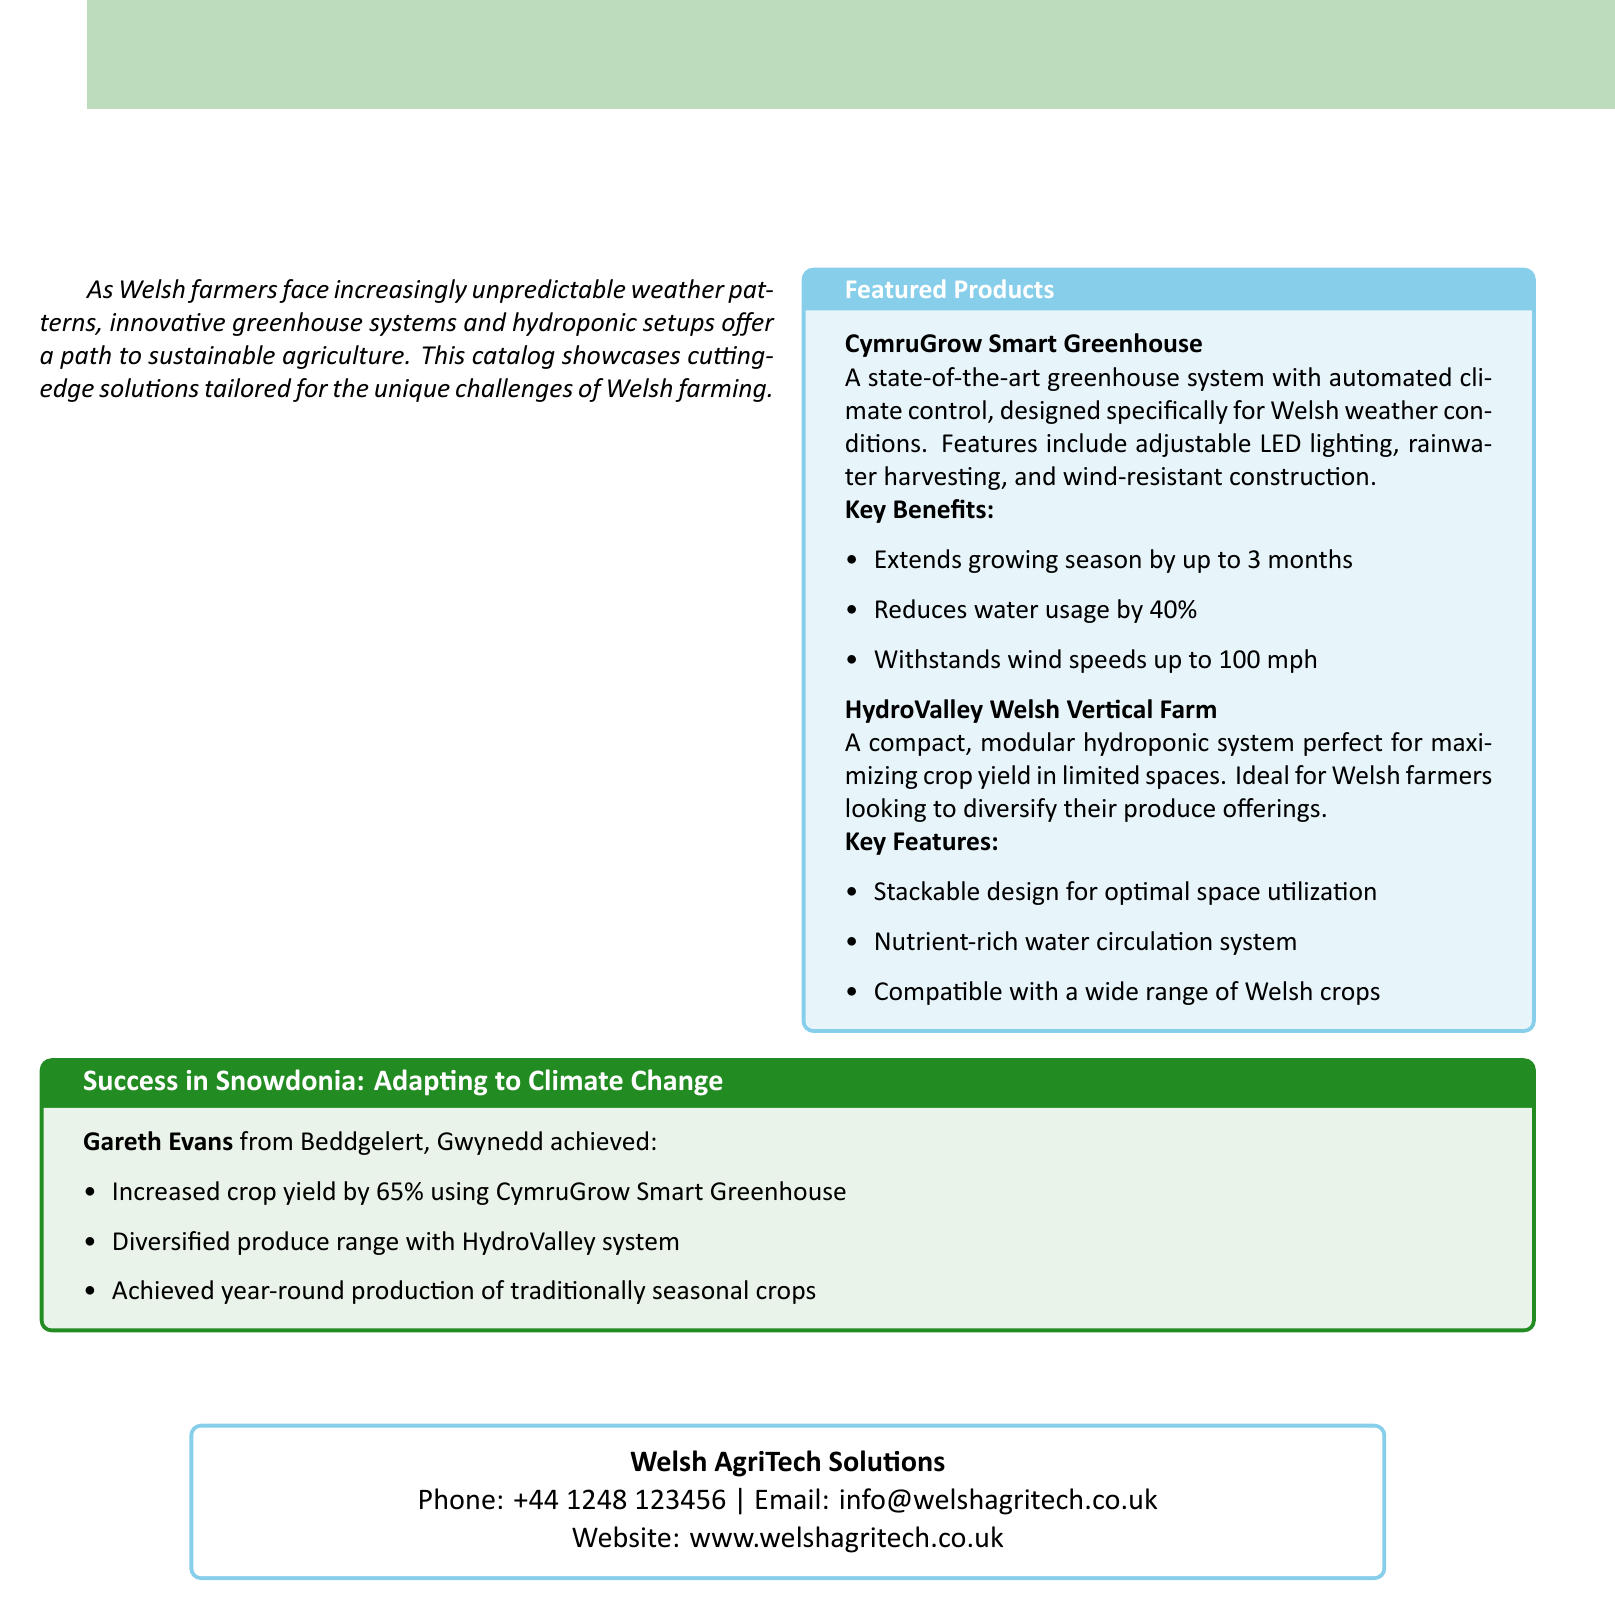What is the name of the smart greenhouse featured? The document explicitly mentions the CymruGrow Smart Greenhouse as the featured product.
Answer: CymruGrow Smart Greenhouse What is one key benefit of the CymruGrow Smart Greenhouse? The document lists several key benefits of the CymruGrow Smart Greenhouse, one of which is extending the growing season by up to 3 months.
Answer: Extends growing season by up to 3 months What type of farming system is the HydroValley? The document categorizes HydroValley as a modular hydroponic system, designed for maximizing crop yield.
Answer: Hydroponic system What percentage reduction in water usage does the CymruGrow offer? The document states that the CymruGrow Smart Greenhouse reduces water usage by 40 percent.
Answer: 40% Who achieved a 65% increase in crop yield? The document mentions Gareth Evans from Beddgelert, Gwynedd as the individual who achieved this increase.
Answer: Gareth Evans What is the primary purpose of the featured products in the catalog? The catalog showcases innovative greenhouse and hydroponic solutions tailored for the challenges faced by Welsh farmers due to unpredictable weather.
Answer: Sustainable agriculture What is the maximum wind speed that the CymruGrow can withstand? According to the document, the CymruGrow Smart Greenhouse can withstand wind speeds up to 100 mph.
Answer: 100 mph Which email address is listed for Welsh AgriTech Solutions? The document provides the contact email address for Welsh AgriTech Solutions.
Answer: info@welshagritech.co.uk 